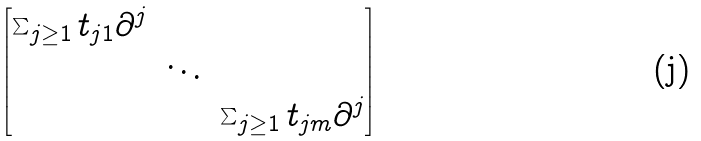Convert formula to latex. <formula><loc_0><loc_0><loc_500><loc_500>\begin{bmatrix} \sum _ { j \geq 1 } t _ { j 1 } \partial ^ { j } \\ & \ddots \\ & & \sum _ { j \geq 1 } t _ { j m } \partial ^ { j } \end{bmatrix}</formula> 